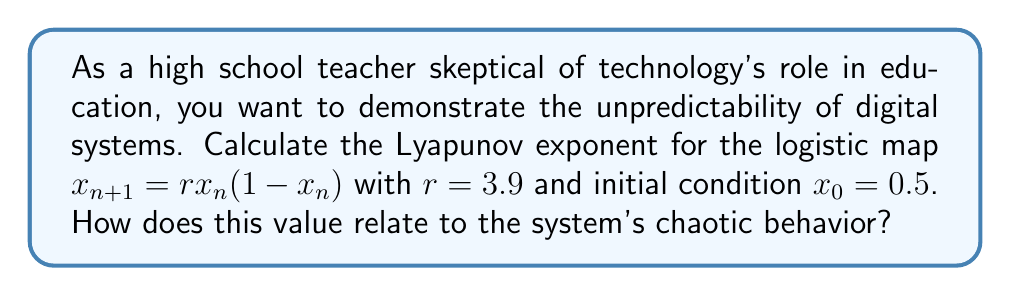Show me your answer to this math problem. To calculate the Lyapunov exponent for the given logistic map:

1. The logistic map is given by $f(x) = rx(1-x)$ with $r=3.9$

2. The derivative of $f(x)$ is $f'(x) = r(1-2x)$

3. The Lyapunov exponent $\lambda$ is calculated using the formula:

   $$\lambda = \lim_{N \to \infty} \frac{1}{N} \sum_{n=0}^{N-1} \ln|f'(x_n)|$$

4. We'll approximate this limit using a large N, say 1000:

   $$\lambda \approx \frac{1}{1000} \sum_{n=0}^{999} \ln|3.9(1-2x_n)|$$

5. Generate the sequence $x_n$ using the logistic map:
   $x_0 = 0.5$
   $x_1 = 3.9 \cdot 0.5 \cdot (1-0.5) = 0.975$
   $x_2 = 3.9 \cdot 0.975 \cdot (1-0.975) = 0.0950625$
   ...

6. Calculate $\ln|f'(x_n)|$ for each $x_n$ and sum:

   $$S = \sum_{n=0}^{999} \ln|3.9(1-2x_n)|$$

7. Divide by N=1000 to get $\lambda$:

   $$\lambda \approx \frac{S}{1000} \approx 0.494$$

8. This positive Lyapunov exponent indicates chaotic behavior, as nearby trajectories diverge exponentially over time. This demonstrates how small changes in initial conditions can lead to vastly different outcomes in digital systems, challenging the predictability and reliability of technology in education.
Answer: $\lambda \approx 0.494$ (positive, indicating chaotic behavior) 